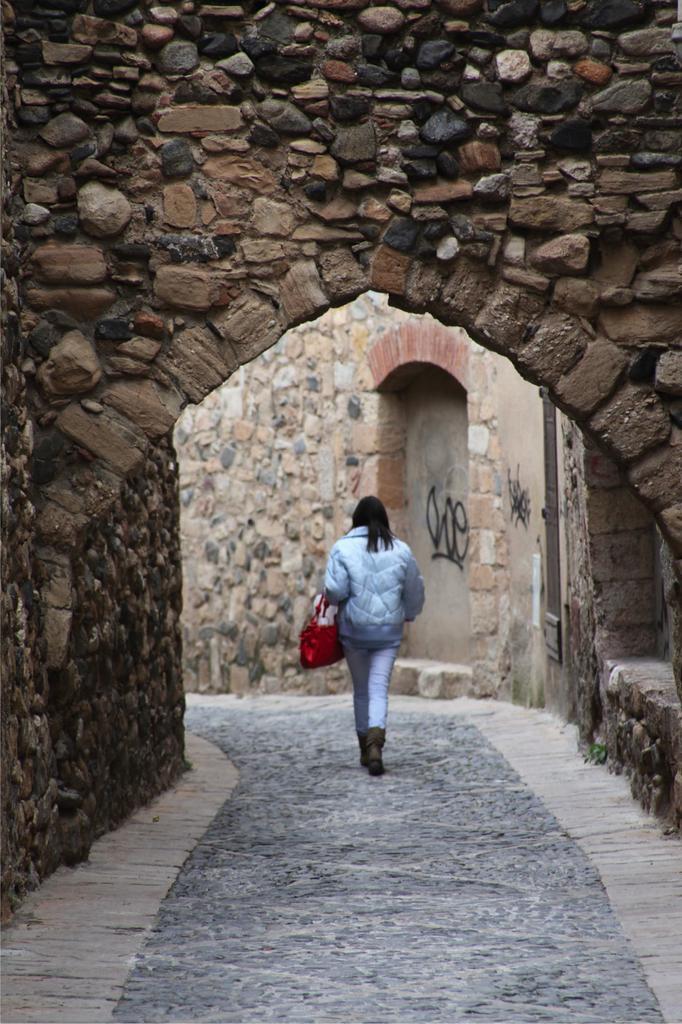Can you describe this image briefly? In the middle a person is walking at the top it is a stone wall. 